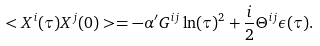<formula> <loc_0><loc_0><loc_500><loc_500>< X ^ { i } ( \tau ) X ^ { j } ( 0 ) > = - \alpha ^ { \prime } G ^ { i j } \ln ( \tau ) ^ { 2 } + \frac { i } { 2 } \Theta ^ { i j } \epsilon ( \tau ) .</formula> 